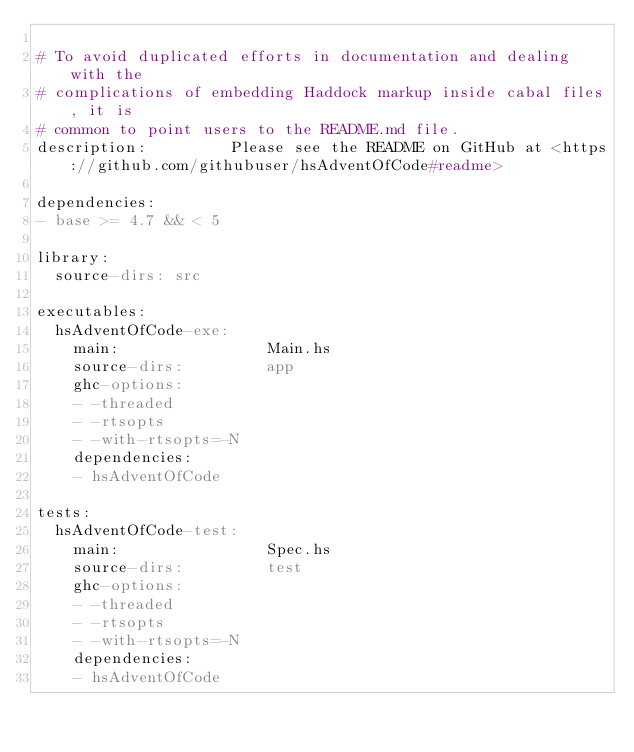Convert code to text. <code><loc_0><loc_0><loc_500><loc_500><_YAML_>
# To avoid duplicated efforts in documentation and dealing with the
# complications of embedding Haddock markup inside cabal files, it is
# common to point users to the README.md file.
description:         Please see the README on GitHub at <https://github.com/githubuser/hsAdventOfCode#readme>

dependencies:
- base >= 4.7 && < 5

library:
  source-dirs: src

executables:
  hsAdventOfCode-exe:
    main:                Main.hs
    source-dirs:         app
    ghc-options:
    - -threaded
    - -rtsopts
    - -with-rtsopts=-N
    dependencies:
    - hsAdventOfCode

tests:
  hsAdventOfCode-test:
    main:                Spec.hs
    source-dirs:         test
    ghc-options:
    - -threaded
    - -rtsopts
    - -with-rtsopts=-N
    dependencies:
    - hsAdventOfCode
</code> 